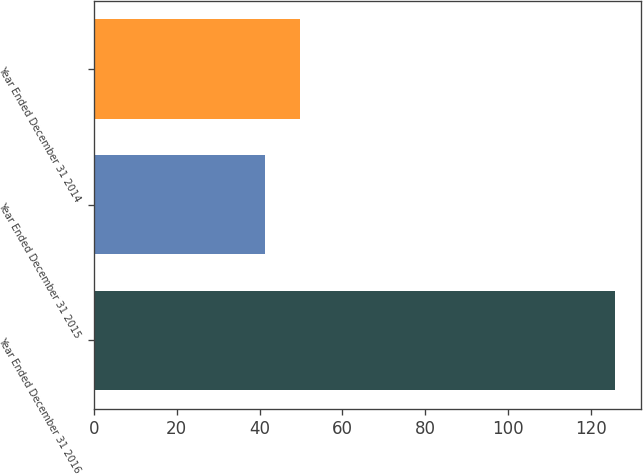<chart> <loc_0><loc_0><loc_500><loc_500><bar_chart><fcel>Year Ended December 31 2016<fcel>Year Ended December 31 2015<fcel>Year Ended December 31 2014<nl><fcel>125.9<fcel>41.4<fcel>49.85<nl></chart> 